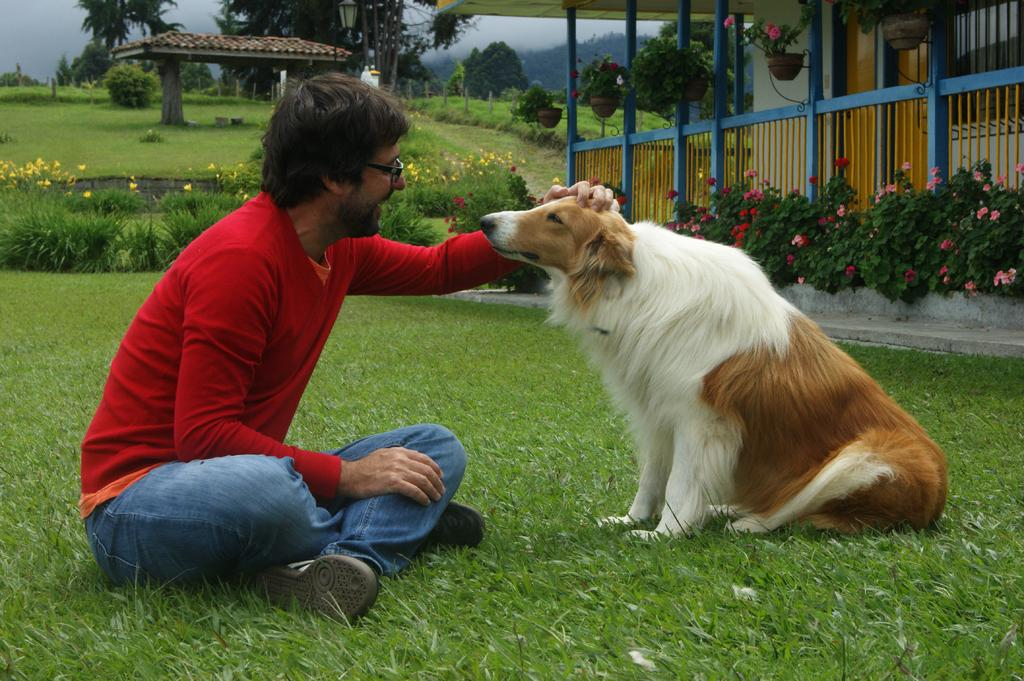What can be seen in the background of the image? There are trees and the sky visible in the background of the image. What is the man in the image doing? The man is sitting on the grass and has his hand over a dog's head. How is the man feeling in the image? The man is smiling in the image. What type of waste is present on the floor in the image? There is no floor or waste present in the image; it features a man sitting on the grass with a dog. 